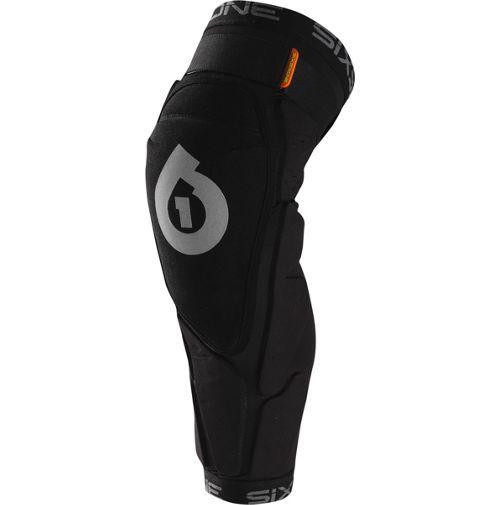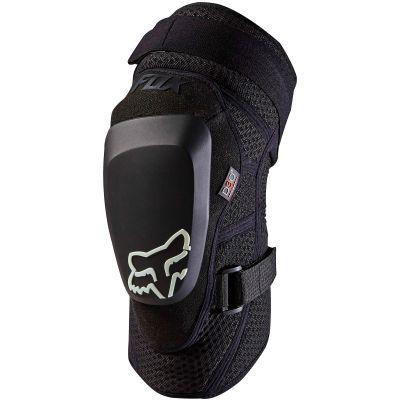The first image is the image on the left, the second image is the image on the right. For the images displayed, is the sentence "The knee braces in the two images face the same direction." factually correct? Answer yes or no. Yes. 